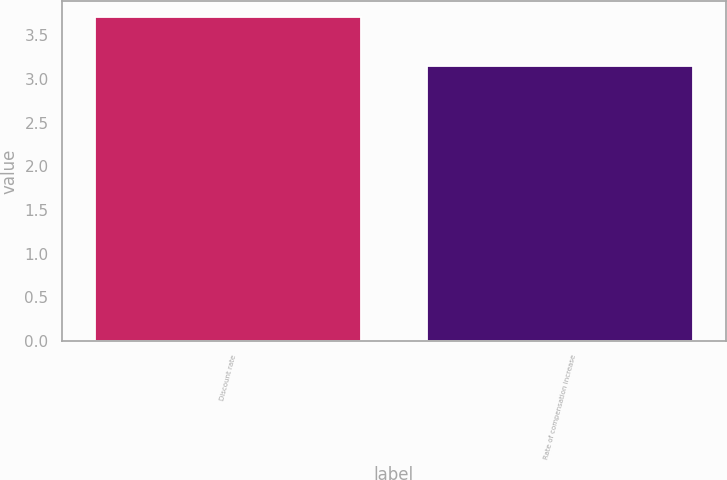Convert chart. <chart><loc_0><loc_0><loc_500><loc_500><bar_chart><fcel>Discount rate<fcel>Rate of compensation increase<nl><fcel>3.71<fcel>3.15<nl></chart> 